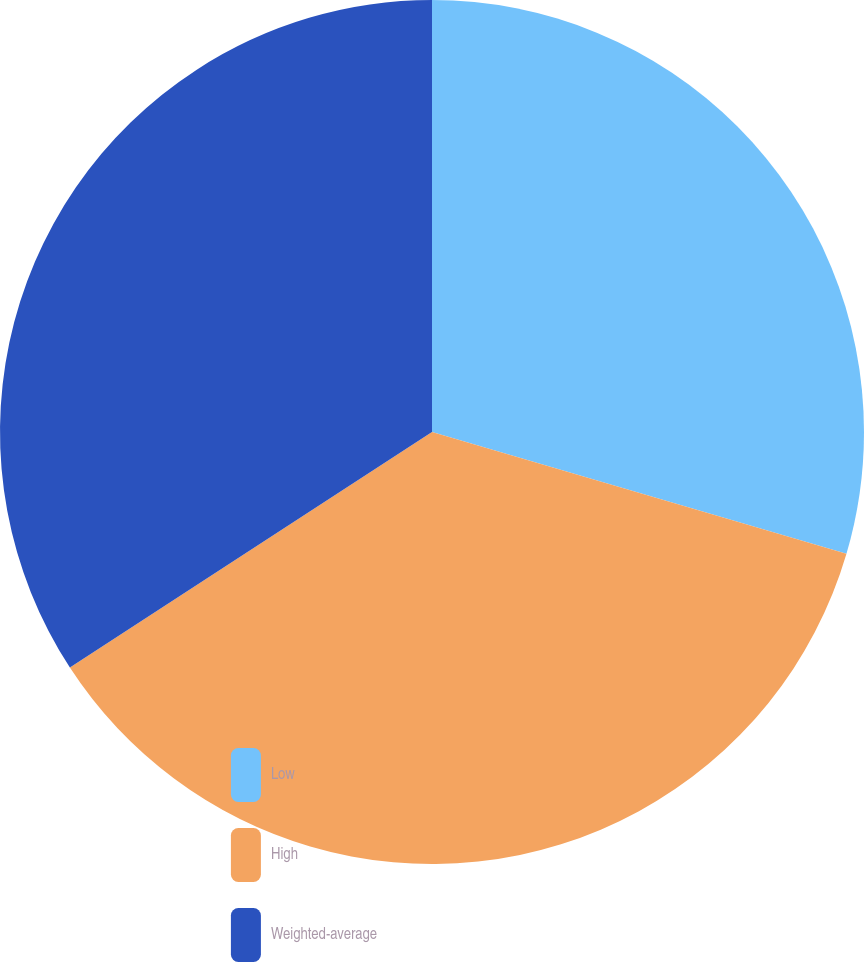Convert chart to OTSL. <chart><loc_0><loc_0><loc_500><loc_500><pie_chart><fcel>Low<fcel>High<fcel>Weighted-average<nl><fcel>29.55%<fcel>36.27%<fcel>34.18%<nl></chart> 